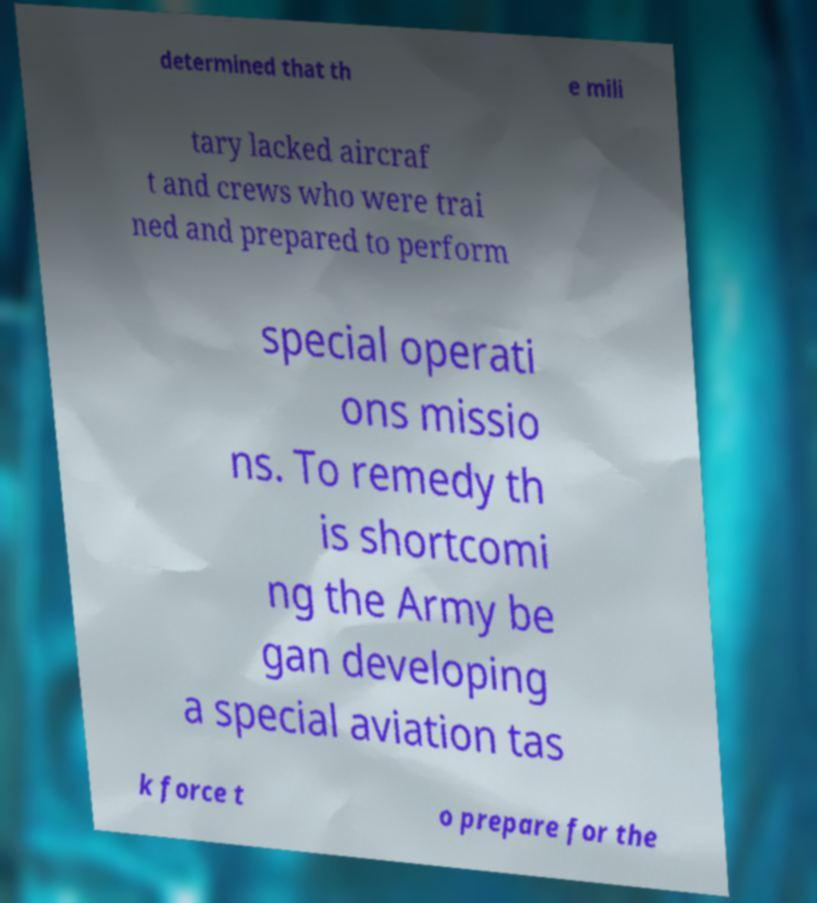What messages or text are displayed in this image? I need them in a readable, typed format. determined that th e mili tary lacked aircraf t and crews who were trai ned and prepared to perform special operati ons missio ns. To remedy th is shortcomi ng the Army be gan developing a special aviation tas k force t o prepare for the 